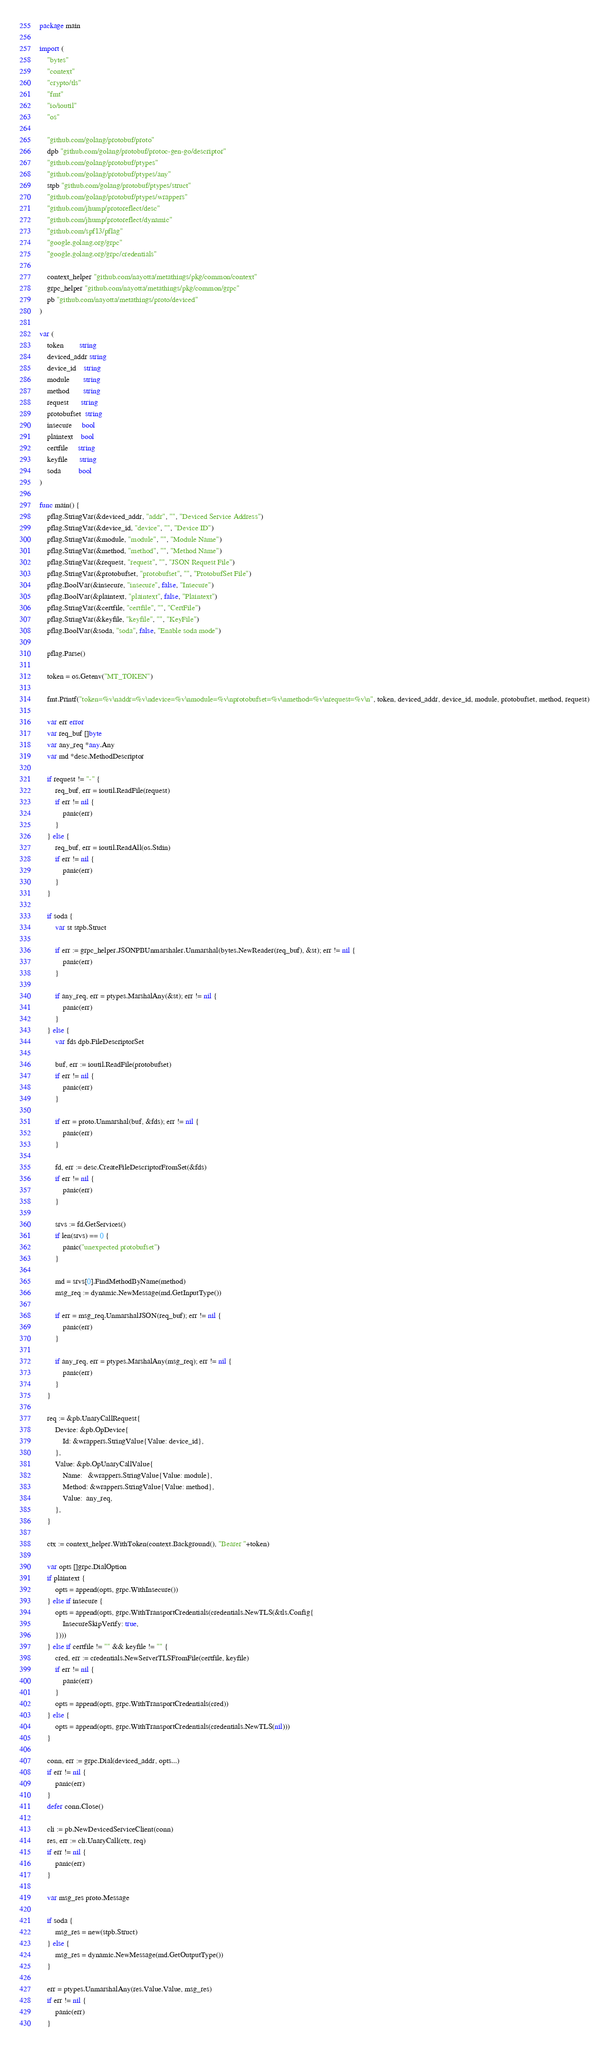<code> <loc_0><loc_0><loc_500><loc_500><_Go_>package main

import (
	"bytes"
	"context"
	"crypto/tls"
	"fmt"
	"io/ioutil"
	"os"

	"github.com/golang/protobuf/proto"
	dpb "github.com/golang/protobuf/protoc-gen-go/descriptor"
	"github.com/golang/protobuf/ptypes"
	"github.com/golang/protobuf/ptypes/any"
	stpb "github.com/golang/protobuf/ptypes/struct"
	"github.com/golang/protobuf/ptypes/wrappers"
	"github.com/jhump/protoreflect/desc"
	"github.com/jhump/protoreflect/dynamic"
	"github.com/spf13/pflag"
	"google.golang.org/grpc"
	"google.golang.org/grpc/credentials"

	context_helper "github.com/nayotta/metathings/pkg/common/context"
	grpc_helper "github.com/nayotta/metathings/pkg/common/grpc"
	pb "github.com/nayotta/metathings/proto/deviced"
)

var (
	token        string
	deviced_addr string
	device_id    string
	module       string
	method       string
	request      string
	protobufset  string
	insecure     bool
	plaintext    bool
	certfile     string
	keyfile      string
	soda         bool
)

func main() {
	pflag.StringVar(&deviced_addr, "addr", "", "Deviced Service Address")
	pflag.StringVar(&device_id, "device", "", "Device ID")
	pflag.StringVar(&module, "module", "", "Module Name")
	pflag.StringVar(&method, "method", "", "Method Name")
	pflag.StringVar(&request, "request", "", "JSON Request File")
	pflag.StringVar(&protobufset, "protobufset", "", "ProtobufSet File")
	pflag.BoolVar(&insecure, "insecure", false, "Insecure")
	pflag.BoolVar(&plaintext, "plaintext", false, "Plaintext")
	pflag.StringVar(&certfile, "certfile", "", "CertFile")
	pflag.StringVar(&keyfile, "keyfile", "", "KeyFile")
	pflag.BoolVar(&soda, "soda", false, "Enable soda mode")

	pflag.Parse()

	token = os.Getenv("MT_TOKEN")

	fmt.Printf("token=%v\naddr=%v\ndevice=%v\nmodule=%v\nprotobufset=%v\nmethod=%v\nrequest=%v\n", token, deviced_addr, device_id, module, protobufset, method, request)

	var err error
	var req_buf []byte
	var any_req *any.Any
	var md *desc.MethodDescriptor

	if request != "-" {
		req_buf, err = ioutil.ReadFile(request)
		if err != nil {
			panic(err)
		}
	} else {
		req_buf, err = ioutil.ReadAll(os.Stdin)
		if err != nil {
			panic(err)
		}
	}

	if soda {
		var st stpb.Struct

		if err := grpc_helper.JSONPBUnmarshaler.Unmarshal(bytes.NewReader(req_buf), &st); err != nil {
			panic(err)
		}

		if any_req, err = ptypes.MarshalAny(&st); err != nil {
			panic(err)
		}
	} else {
		var fds dpb.FileDescriptorSet

		buf, err := ioutil.ReadFile(protobufset)
		if err != nil {
			panic(err)
		}

		if err = proto.Unmarshal(buf, &fds); err != nil {
			panic(err)
		}

		fd, err := desc.CreateFileDescriptorFromSet(&fds)
		if err != nil {
			panic(err)
		}

		srvs := fd.GetServices()
		if len(srvs) == 0 {
			panic("unexpected protobufset")
		}

		md = srvs[0].FindMethodByName(method)
		msg_req := dynamic.NewMessage(md.GetInputType())

		if err = msg_req.UnmarshalJSON(req_buf); err != nil {
			panic(err)
		}

		if any_req, err = ptypes.MarshalAny(msg_req); err != nil {
			panic(err)
		}
	}

	req := &pb.UnaryCallRequest{
		Device: &pb.OpDevice{
			Id: &wrappers.StringValue{Value: device_id},
		},
		Value: &pb.OpUnaryCallValue{
			Name:   &wrappers.StringValue{Value: module},
			Method: &wrappers.StringValue{Value: method},
			Value:  any_req,
		},
	}

	ctx := context_helper.WithToken(context.Background(), "Bearer "+token)

	var opts []grpc.DialOption
	if plaintext {
		opts = append(opts, grpc.WithInsecure())
	} else if insecure {
		opts = append(opts, grpc.WithTransportCredentials(credentials.NewTLS(&tls.Config{
			InsecureSkipVerify: true,
		})))
	} else if certfile != "" && keyfile != "" {
		cred, err := credentials.NewServerTLSFromFile(certfile, keyfile)
		if err != nil {
			panic(err)
		}
		opts = append(opts, grpc.WithTransportCredentials(cred))
	} else {
		opts = append(opts, grpc.WithTransportCredentials(credentials.NewTLS(nil)))
	}

	conn, err := grpc.Dial(deviced_addr, opts...)
	if err != nil {
		panic(err)
	}
	defer conn.Close()

	cli := pb.NewDevicedServiceClient(conn)
	res, err := cli.UnaryCall(ctx, req)
	if err != nil {
		panic(err)
	}

	var msg_res proto.Message

	if soda {
		msg_res = new(stpb.Struct)
	} else {
		msg_res = dynamic.NewMessage(md.GetOutputType())
	}

	err = ptypes.UnmarshalAny(res.Value.Value, msg_res)
	if err != nil {
		panic(err)
	}
</code> 